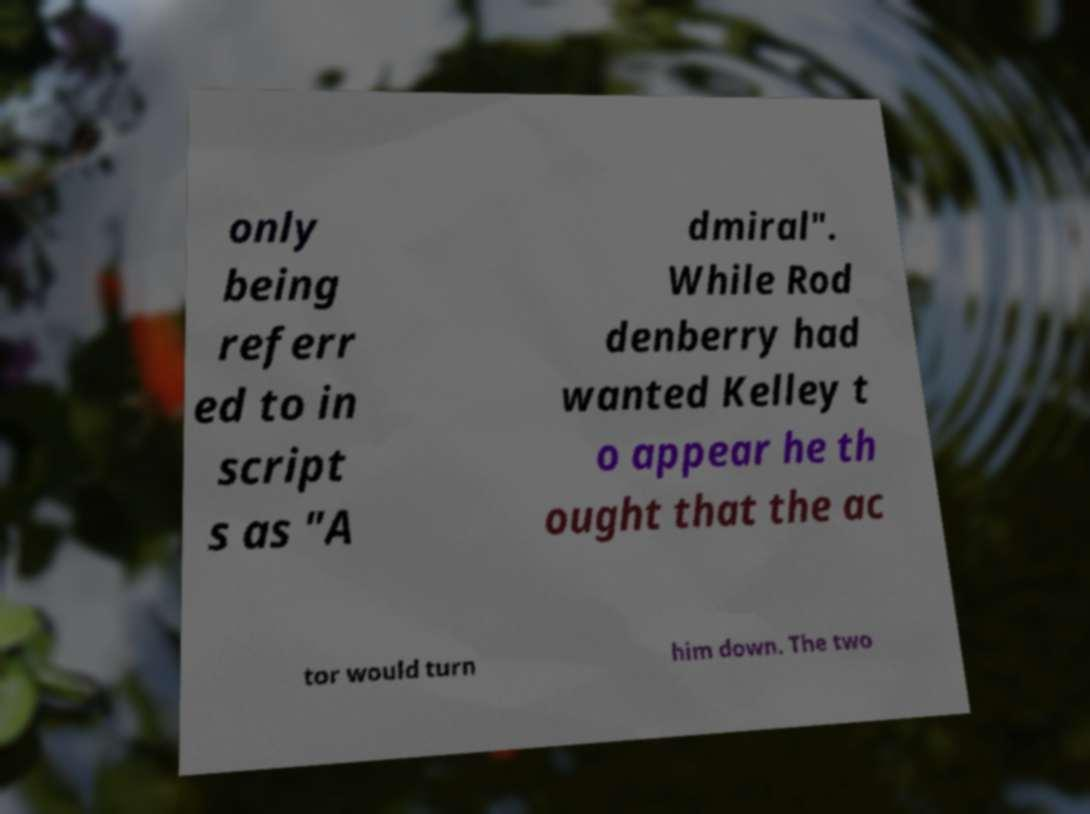I need the written content from this picture converted into text. Can you do that? only being referr ed to in script s as "A dmiral". While Rod denberry had wanted Kelley t o appear he th ought that the ac tor would turn him down. The two 